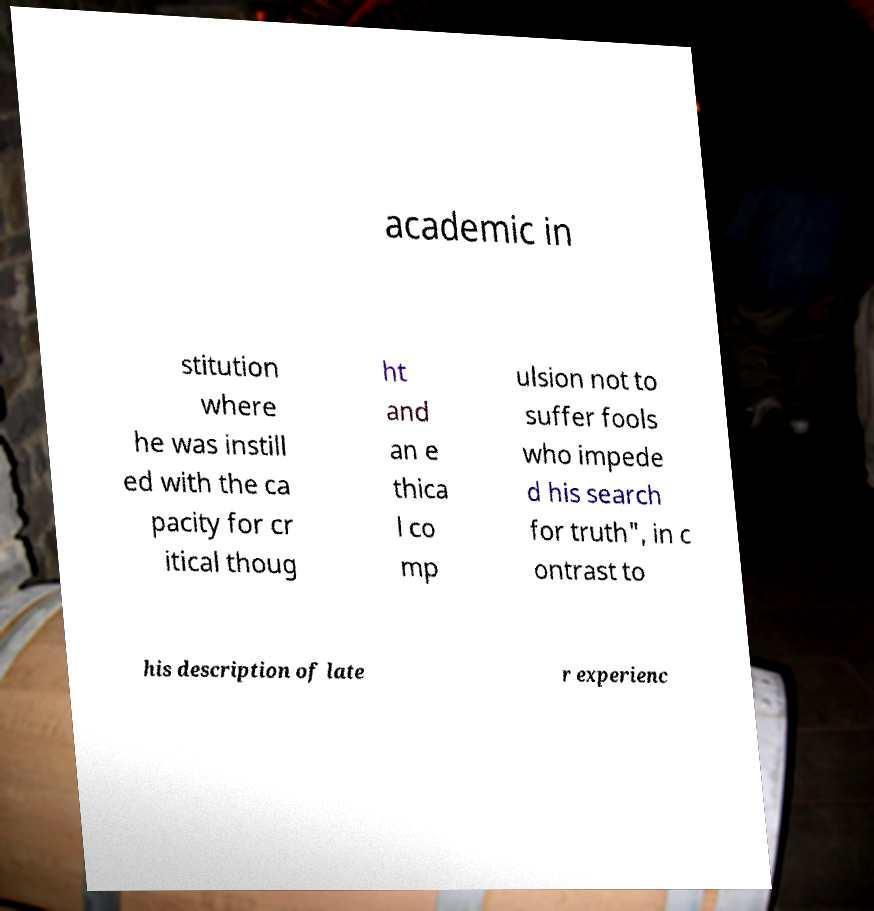Please read and relay the text visible in this image. What does it say? academic in stitution where he was instill ed with the ca pacity for cr itical thoug ht and an e thica l co mp ulsion not to suffer fools who impede d his search for truth", in c ontrast to his description of late r experienc 